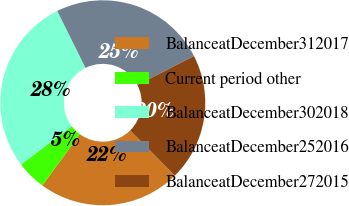Convert chart to OTSL. <chart><loc_0><loc_0><loc_500><loc_500><pie_chart><fcel>BalanceatDecember312017<fcel>Current period other<fcel>BalanceatDecember302018<fcel>BalanceatDecember252016<fcel>BalanceatDecember272015<nl><fcel>22.46%<fcel>4.65%<fcel>27.98%<fcel>24.79%<fcel>20.12%<nl></chart> 